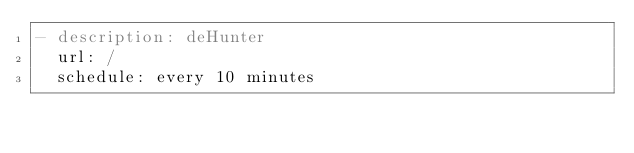Convert code to text. <code><loc_0><loc_0><loc_500><loc_500><_YAML_>- description: deHunter
  url: /
  schedule: every 10 minutes
</code> 